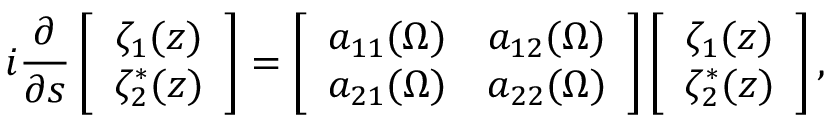Convert formula to latex. <formula><loc_0><loc_0><loc_500><loc_500>i \frac { \partial } { \partial s } \left [ \begin{array} { c } { \zeta _ { 1 } ( z ) } \\ { \zeta _ { 2 } ^ { \ast } ( z ) } \end{array} \right ] = \left [ \begin{array} { c c } { a _ { 1 1 } ( \Omega ) } & { a _ { 1 2 } ( \Omega ) } \\ { a _ { 2 1 } ( \Omega ) } & { a _ { 2 2 } ( \Omega ) } \end{array} \right ] \left [ \begin{array} { c } { \zeta _ { 1 } ( z ) } \\ { \zeta _ { 2 } ^ { \ast } ( z ) } \end{array} \right ] ,</formula> 